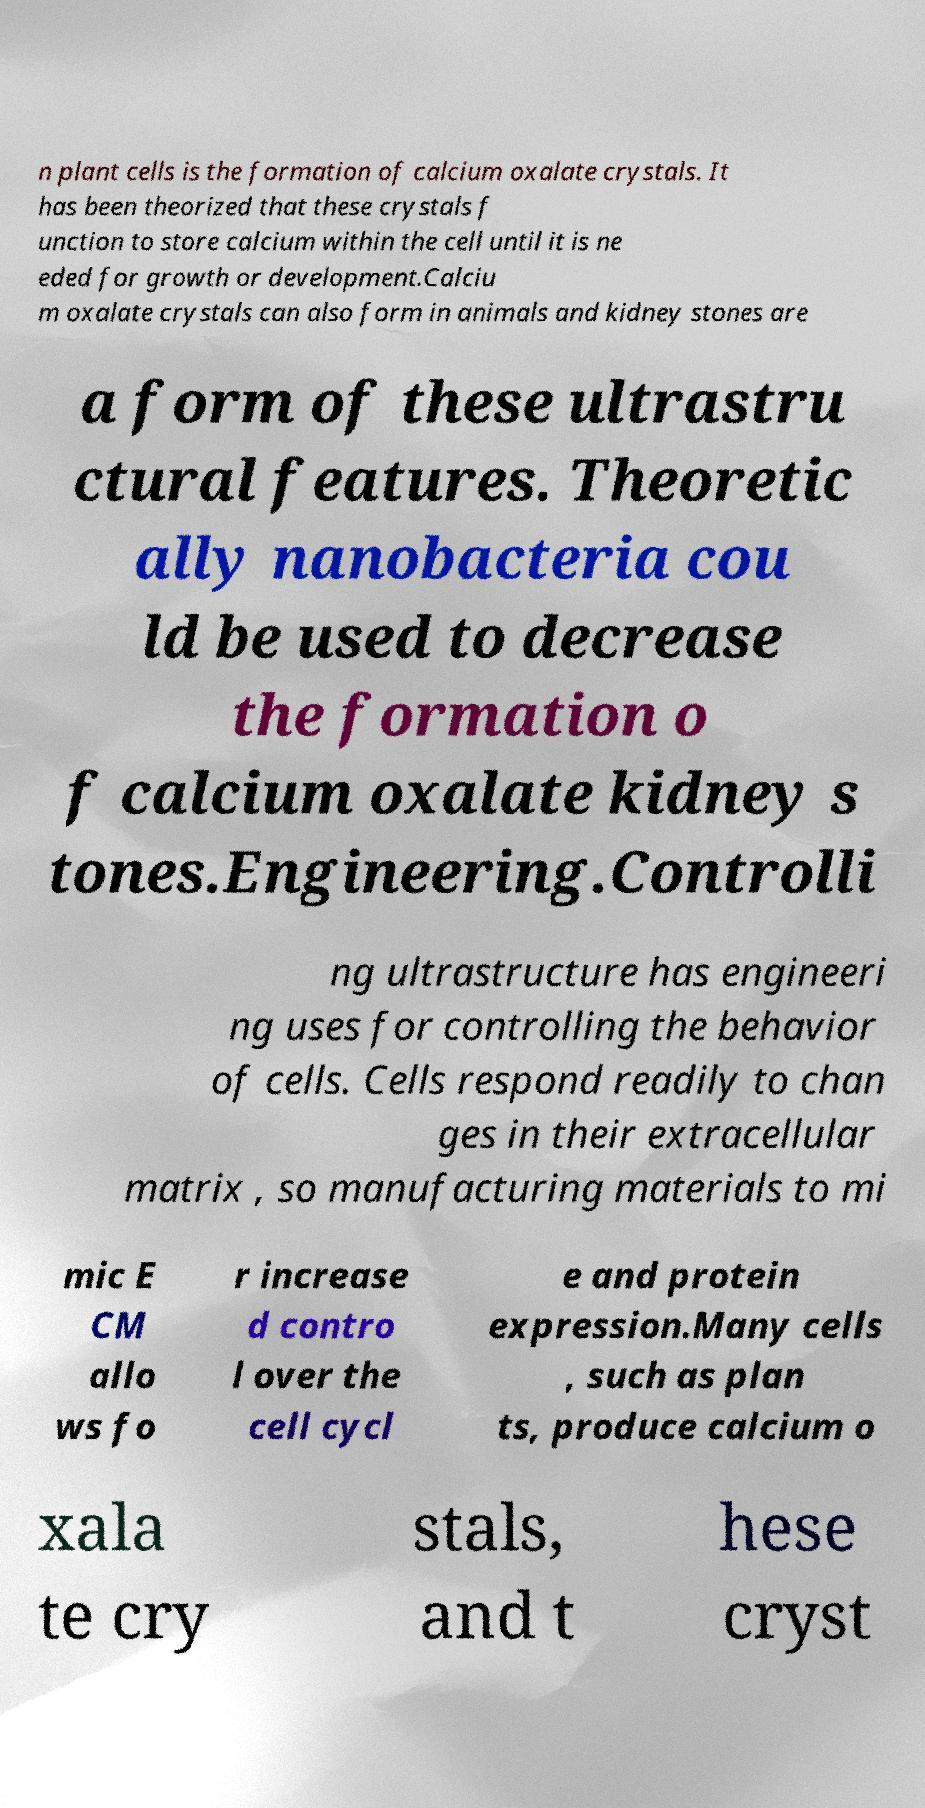I need the written content from this picture converted into text. Can you do that? n plant cells is the formation of calcium oxalate crystals. It has been theorized that these crystals f unction to store calcium within the cell until it is ne eded for growth or development.Calciu m oxalate crystals can also form in animals and kidney stones are a form of these ultrastru ctural features. Theoretic ally nanobacteria cou ld be used to decrease the formation o f calcium oxalate kidney s tones.Engineering.Controlli ng ultrastructure has engineeri ng uses for controlling the behavior of cells. Cells respond readily to chan ges in their extracellular matrix , so manufacturing materials to mi mic E CM allo ws fo r increase d contro l over the cell cycl e and protein expression.Many cells , such as plan ts, produce calcium o xala te cry stals, and t hese cryst 